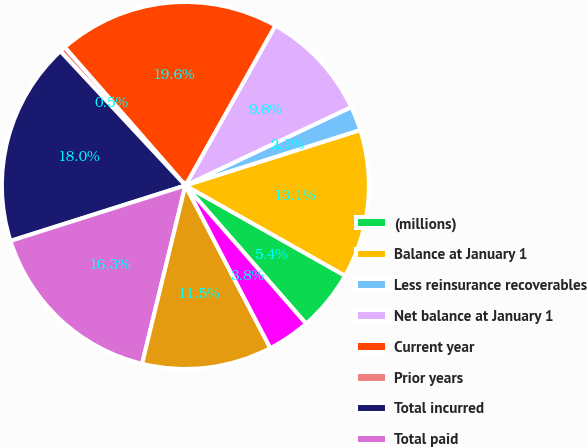Convert chart. <chart><loc_0><loc_0><loc_500><loc_500><pie_chart><fcel>(millions)<fcel>Balance at January 1<fcel>Less reinsurance recoverables<fcel>Net balance at January 1<fcel>Current year<fcel>Prior years<fcel>Total incurred<fcel>Total paid<fcel>Net balance at December 31<fcel>Plus reinsurance recoverables<nl><fcel>5.39%<fcel>13.07%<fcel>2.14%<fcel>9.82%<fcel>19.57%<fcel>0.51%<fcel>17.95%<fcel>16.32%<fcel>11.45%<fcel>3.76%<nl></chart> 